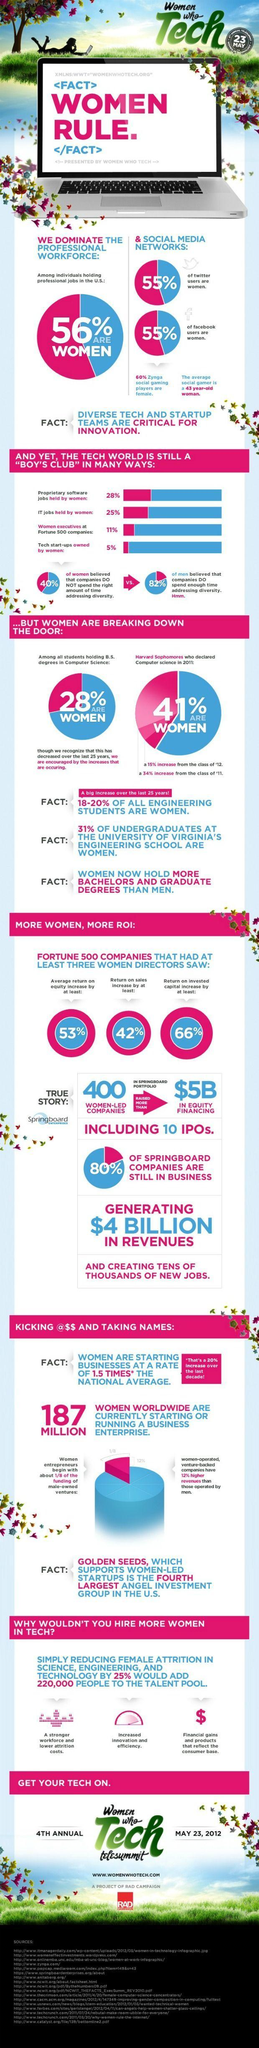What is the percentage of men executives at Fortune 500 companies?
Answer the question with a short phrase. 89% What percent of the proprietary software jobs in the U.S. were held by men? 72% What percentage of facebook users in the U.S. are men? 45% What percentage of the professional workforce in the U.S. are men? 44% What percent of the tech start-ups were owned by men? 95% What percentage of twitter users in the U.S. are men? 45% 